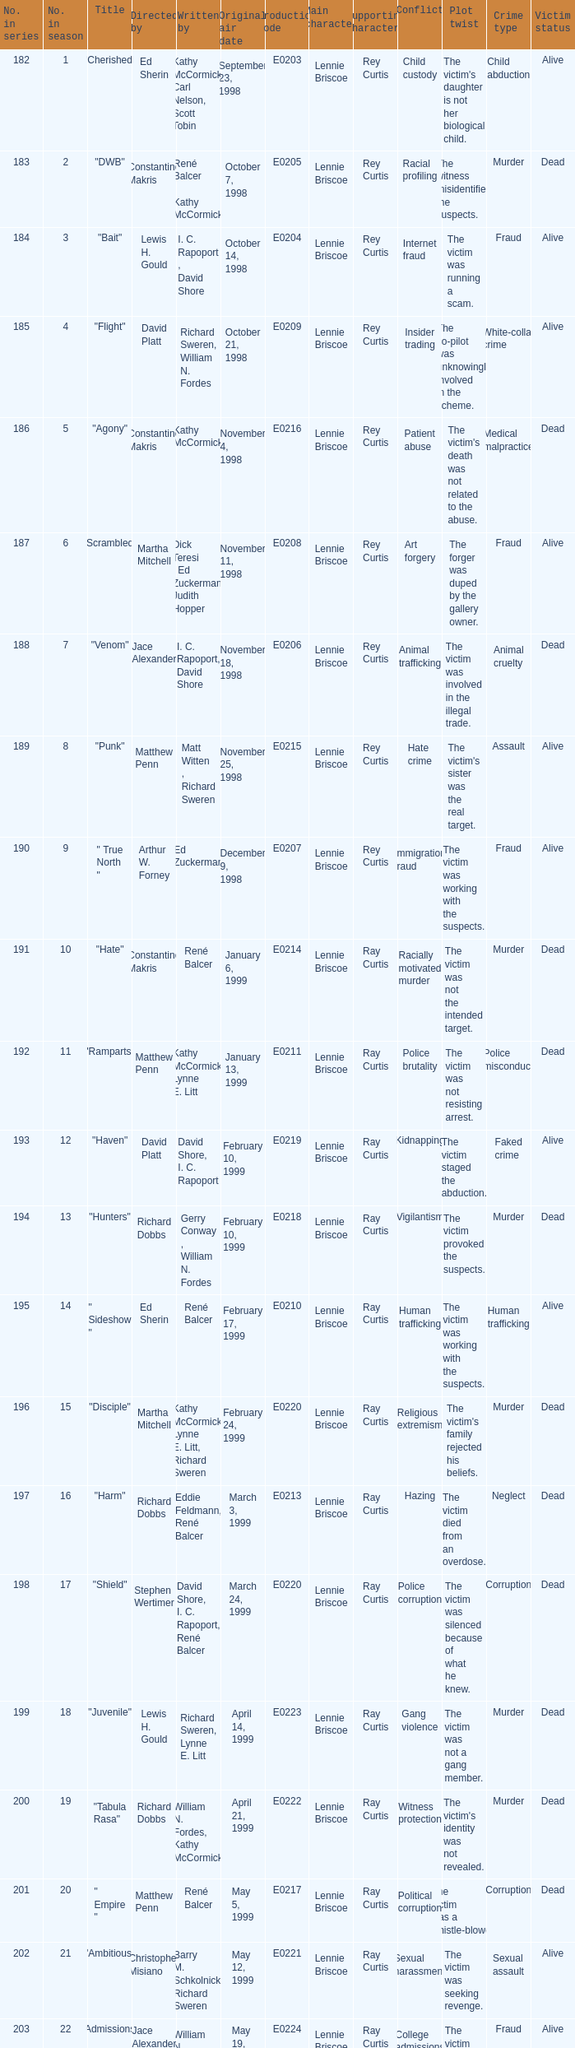What is the season number of the episode written by Matt Witten , Richard Sweren? 8.0. 